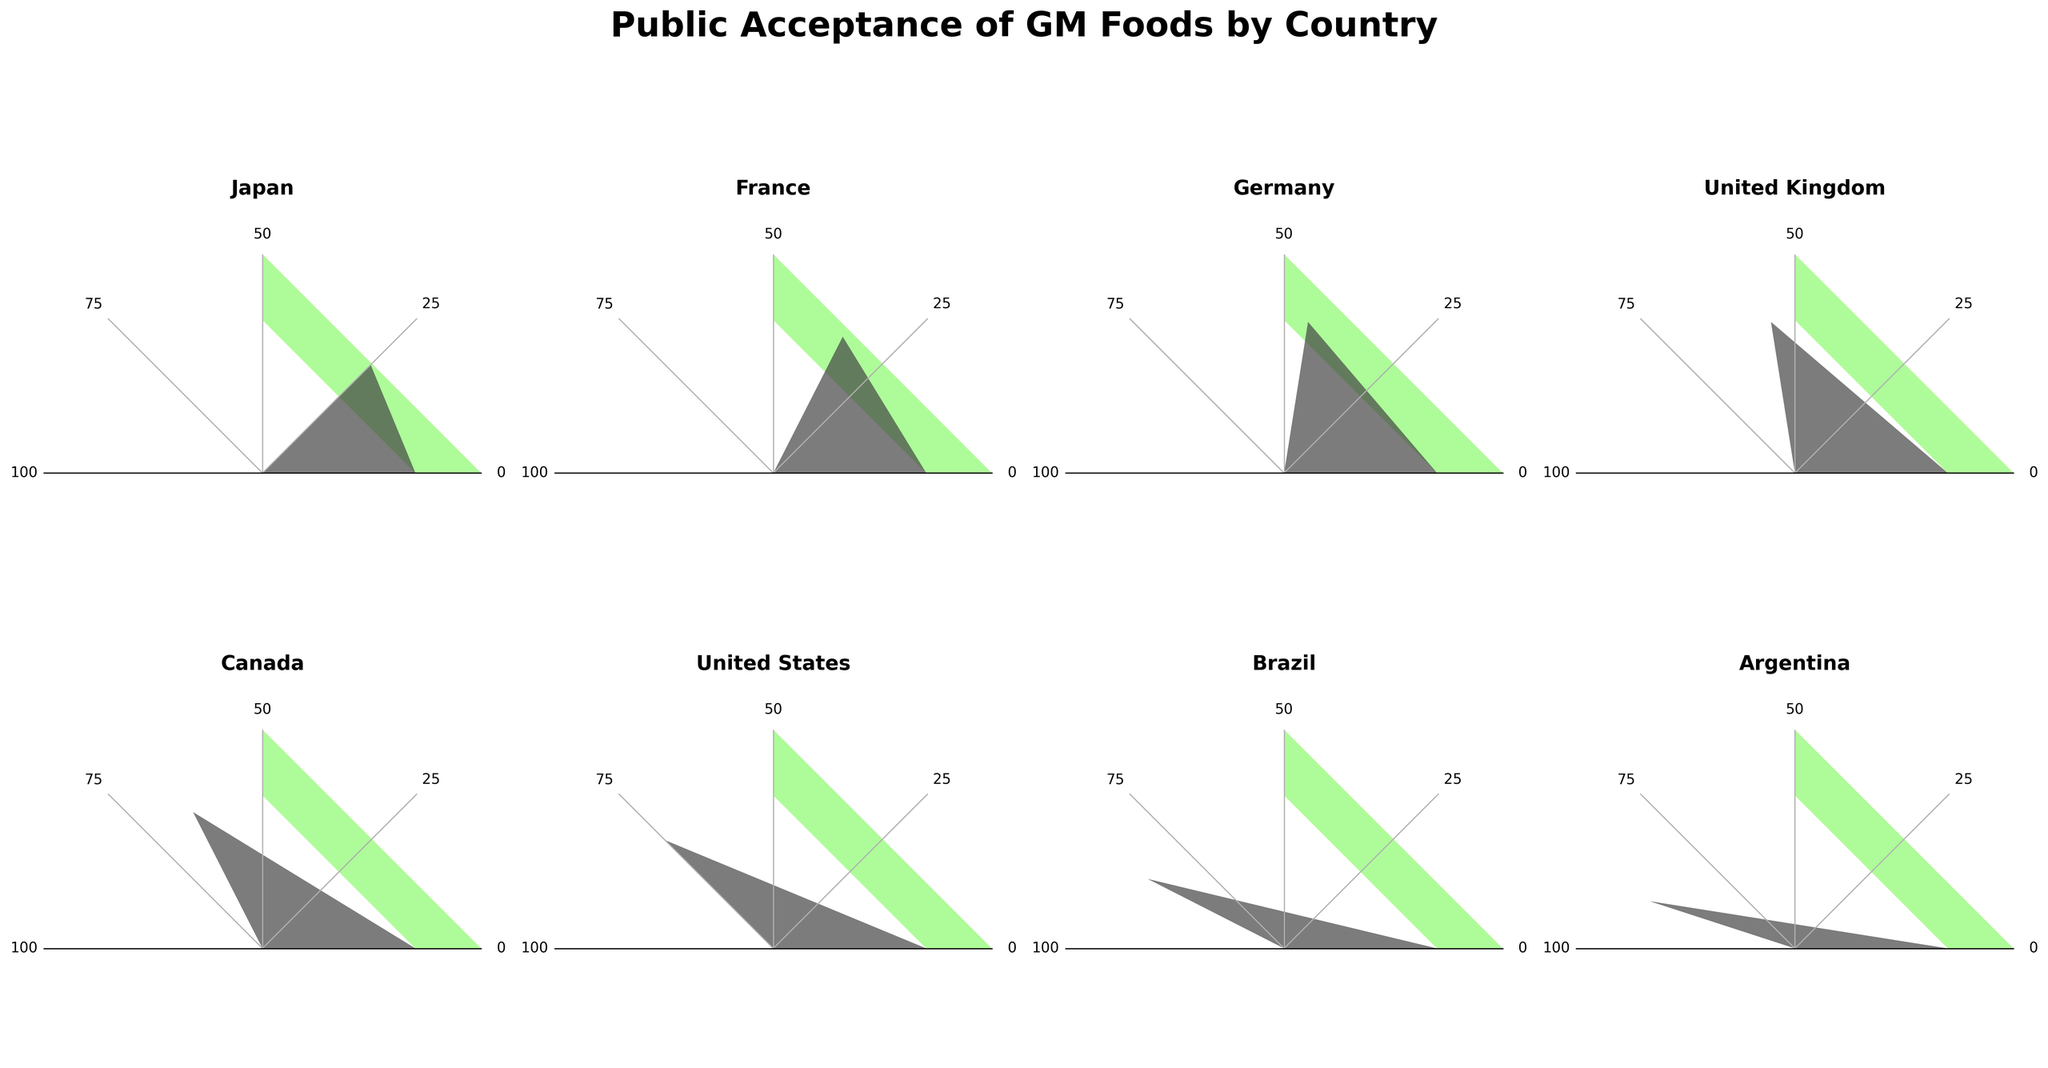What's the acceptance level of GM foods in the United States? The figure shows the public acceptance levels of GM foods in different countries. For the United States, the acceptance level on the gauge chart is indicated as 75%.
Answer: 75% What country has the highest public acceptance of GM foods? By examining the figures for each country, Argentina has the needle closest to the highest percentage, showing 90%.
Answer: Argentina What is the difference in acceptance levels between France and the United Kingdom? France has an acceptance level of 35%, and the United Kingdom has 55%. The difference is calculated as 55% - 35% = 20%.
Answer: 20% What is the median acceptance level of all listed countries? To find the median, first arrange the acceptance levels in ascending order: 25, 35, 45, 55, 65, 75, 85, 90. With an even number of values, the median is the average of the middle two values (55 and 65), thus (55 + 65) / 2 = 60.
Answer: 60 Which country has a lower acceptance level of GM foods, Germany or Canada? Germany's acceptance level is 45%, while Canada's is 65%. Therefore, Germany has a lower acceptance level.
Answer: Germany What's the overall trend seen in the acceptance of GM foods among these countries? By visually inspecting the gauge charts, we notice that acceptance generally increases from Japan (lowest) to Argentina (highest).
Answer: Increasing trend Which country is most neutral (closest to 50%) in terms of acceptance level? The acceptance closest to 50% is the one of the United Kingdom with 55%.
Answer: United Kingdom How many countries have an acceptance level of GM foods below 50%? By counting the countries with acceptance levels below 50%, we find Japan (25%), France (35%), and Germany (45%). So, there are 3 countries.
Answer: 3 Which regions (countries) show more positive acceptance levels (closer to or above 75%)? From the figure, the United States (75%), Brazil (85%), and Argentina (90%) show more positive acceptance levels, all being 75% or above.
Answer: United States, Brazil, Argentina 